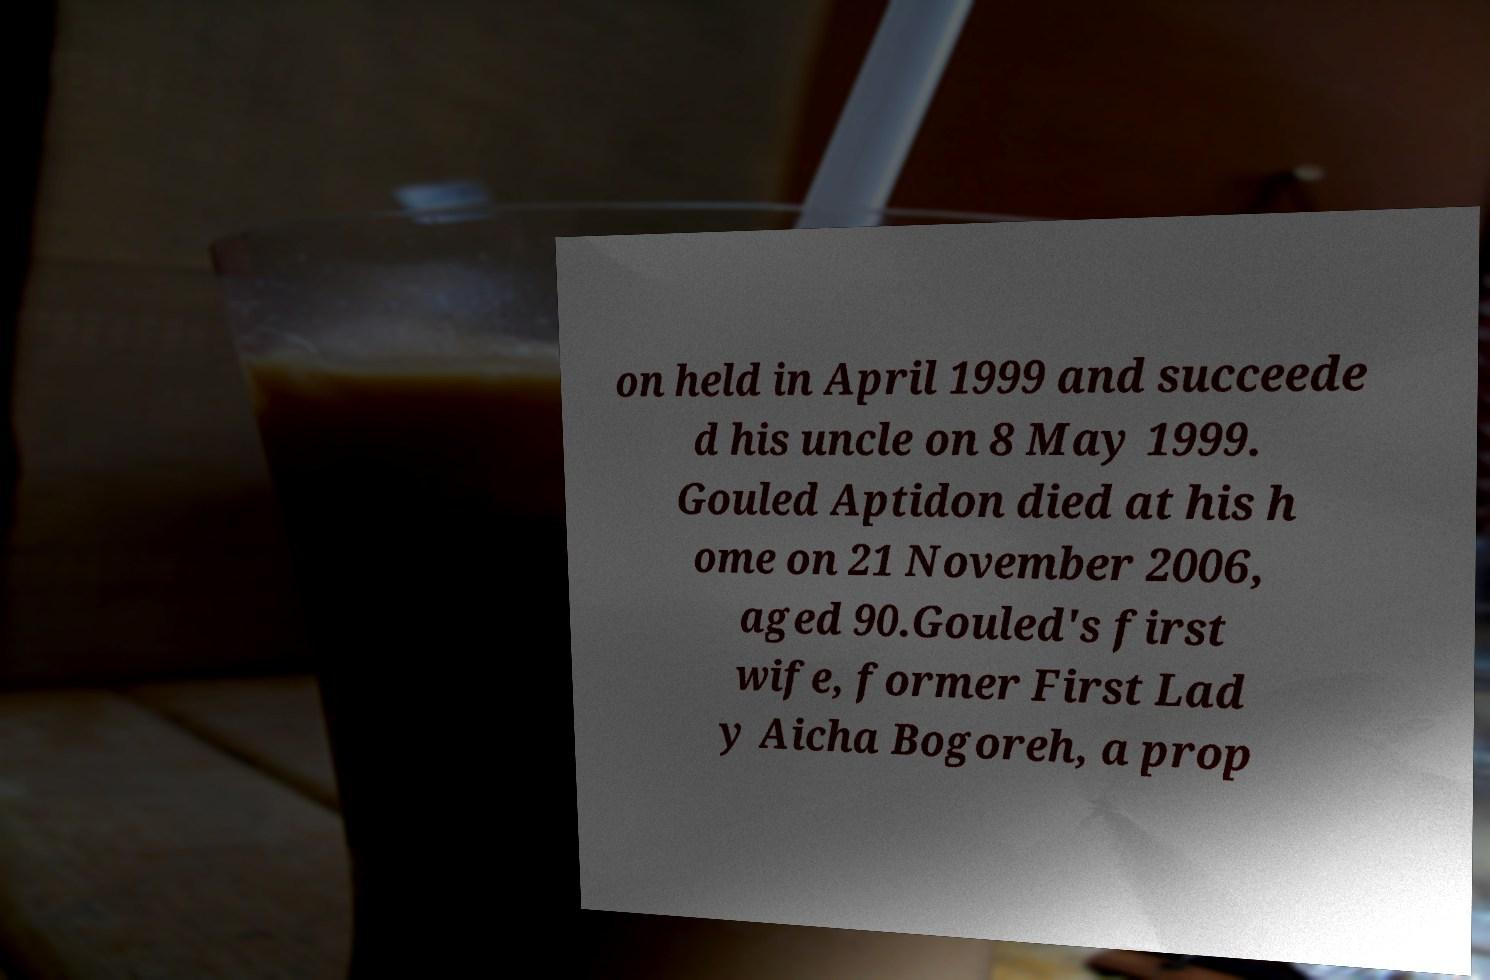Please read and relay the text visible in this image. What does it say? on held in April 1999 and succeede d his uncle on 8 May 1999. Gouled Aptidon died at his h ome on 21 November 2006, aged 90.Gouled's first wife, former First Lad y Aicha Bogoreh, a prop 